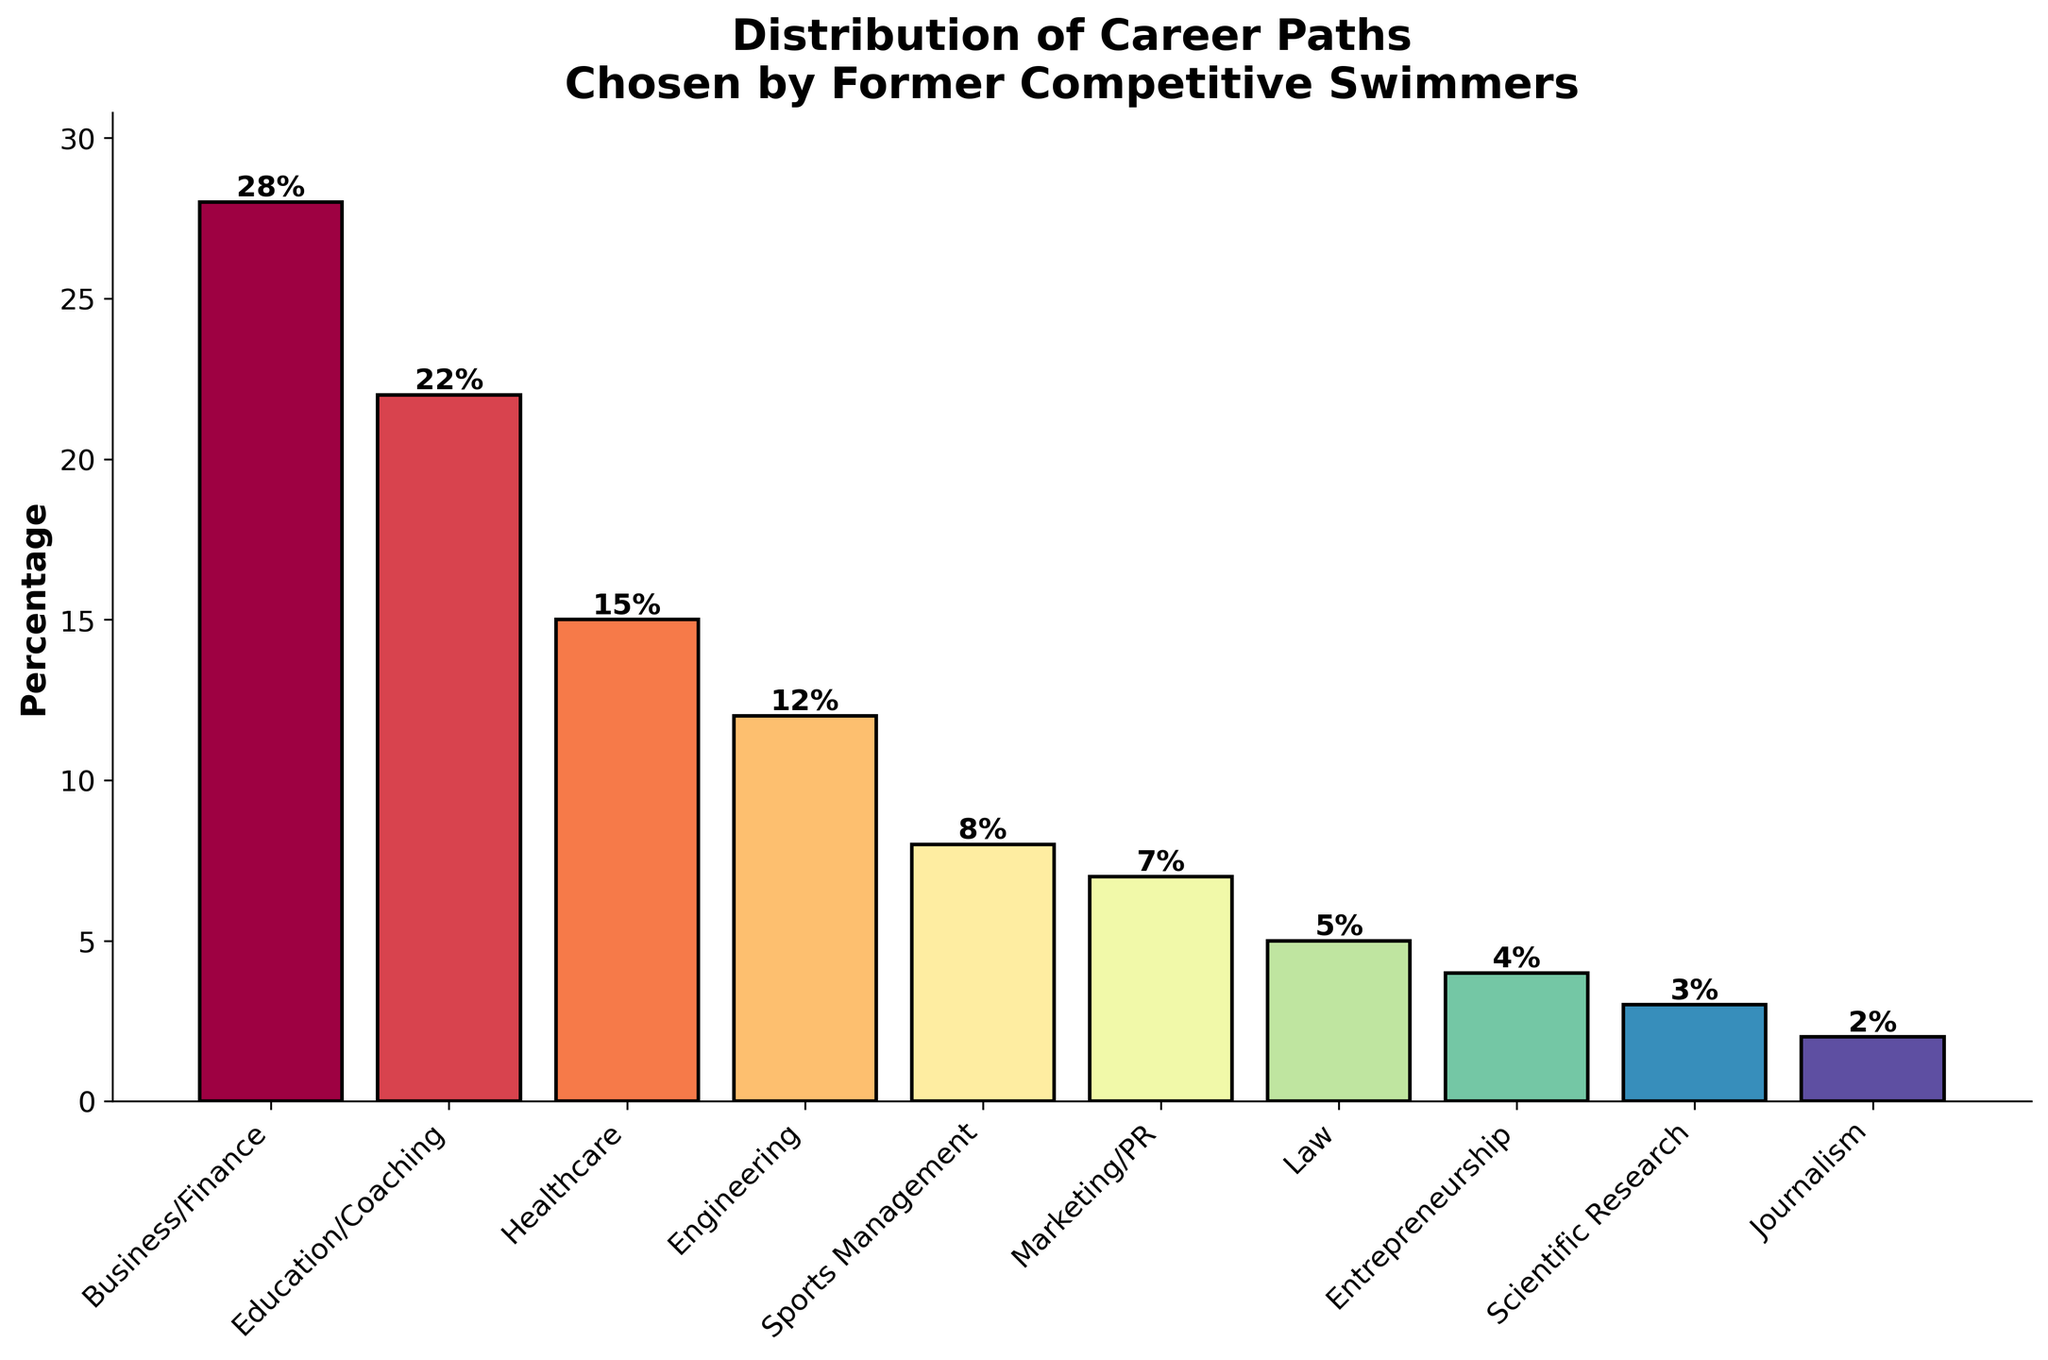What is the career path with the highest percentage? To determine which career path has the highest percentage, we look for the tallest bar in the bar chart. According to the data provided, Business/Finance has the highest percentage at 28%.
Answer: Business/Finance Which career paths have percentages equal to or greater than 20%? We need to find bars that have a height of 20% or more. Based on the bar chart, Business/Finance (28%) and Education/Coaching (22%) meet this criterion.
Answer: Business/Finance, Education/Coaching How many career paths have a percentage less than 10%? Identify the bars that have heights less than 10%. The career paths are Sports Management (8%), Marketing/PR (7%), Law (5%), Entrepreneurship (4%), Scientific Research (3%), and Journalism (2%). Counting these up, there are six such career paths.
Answer: 6 What is the total percentage for Healthcare and Engineering combined? To find the total percentage of Healthcare and Engineering, add their respective percentages. Healthcare is 15% and Engineering is 12%. Their combined percentage is 15% + 12% = 27%.
Answer: 27% Which career path follows Engineering in terms of percentage? Find the bar corresponding to Engineering and look for the next shorter bar. Engineering stands at 12%, and the next shortest bar is Sports Management at 8%.
Answer: Sports Management Is the percentage of people choosing Entrepreneurship greater than that of Scientific Research? Compare the heights of the bars for Entrepreneurship and Scientific Research. Entrepreneurship is at 4%, whereas Scientific Research is at 3%. Thus, Entrepreneurship has a higher percentage.
Answer: Yes What is the sum of the percentages for the four most common career paths? Identify the four tallest bars and sum their percentages: Business/Finance (28%), Education/Coaching (22%), Healthcare (15%), and Engineering (12%). The total percentage is 28% + 22% + 15% + 12% = 77%.
Answer: 77% Which career path has 7 percent of the former competitive swimmers? Look for the bar that corresponds to 7% and identify the career path. Marketing/PR has a percentage of 7%.
Answer: Marketing/PR By how much does the percentage of those in Business/Finance exceed those in Education/Coaching? Subtract the percentage of Education/Coaching from that of Business/Finance. Business/Finance is at 28%, and Education/Coaching is at 22%. The difference is 28% - 22% = 6%.
Answer: 6% 